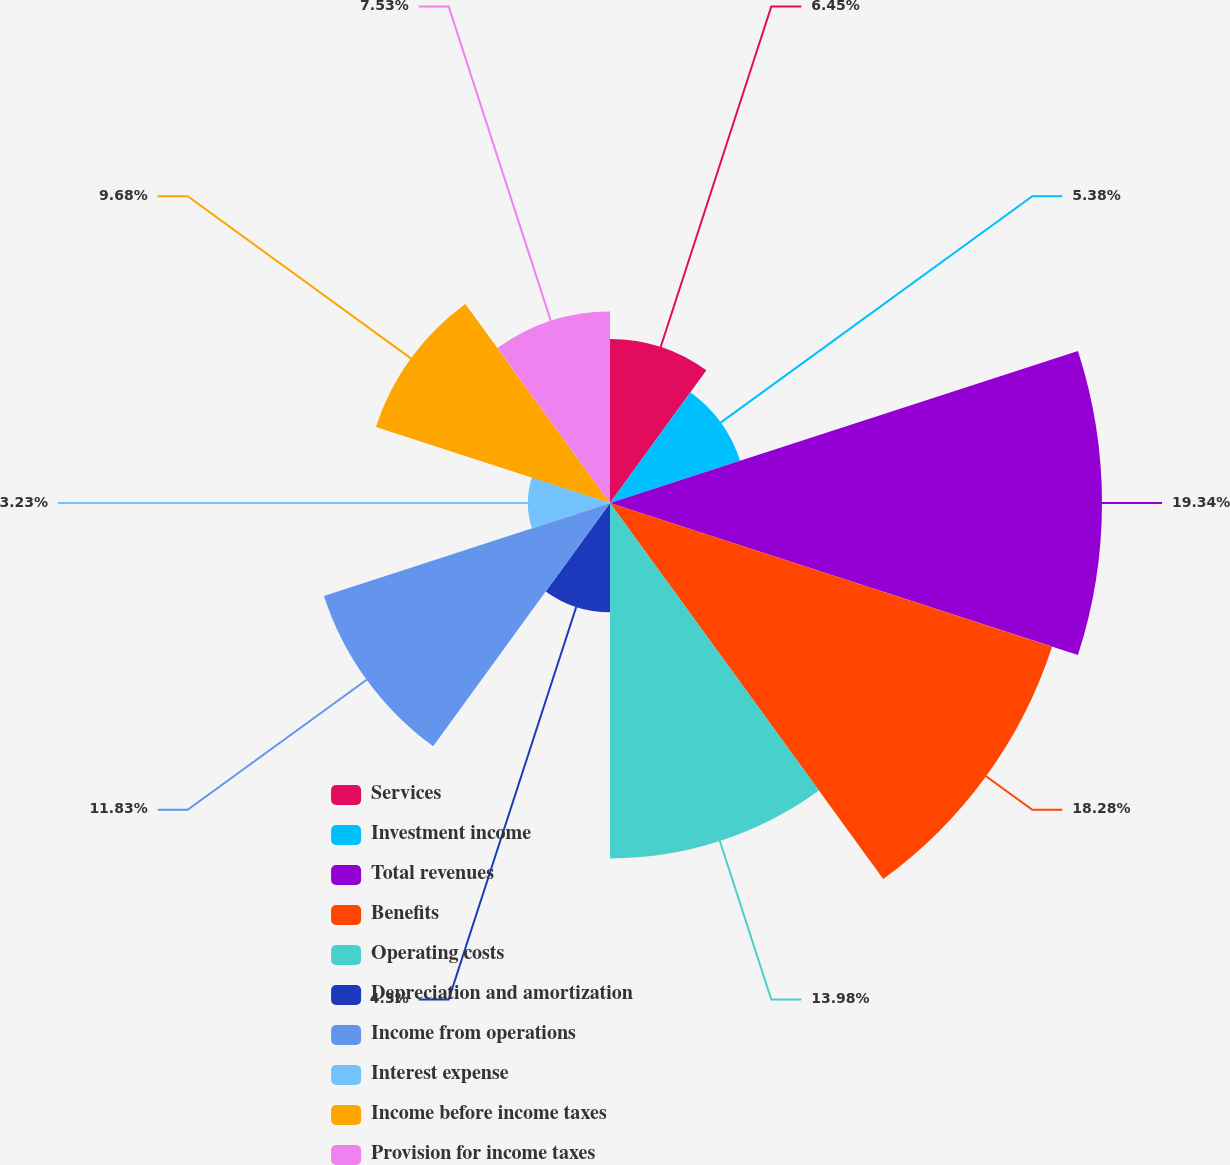Convert chart to OTSL. <chart><loc_0><loc_0><loc_500><loc_500><pie_chart><fcel>Services<fcel>Investment income<fcel>Total revenues<fcel>Benefits<fcel>Operating costs<fcel>Depreciation and amortization<fcel>Income from operations<fcel>Interest expense<fcel>Income before income taxes<fcel>Provision for income taxes<nl><fcel>6.45%<fcel>5.38%<fcel>19.35%<fcel>18.28%<fcel>13.98%<fcel>4.3%<fcel>11.83%<fcel>3.23%<fcel>9.68%<fcel>7.53%<nl></chart> 